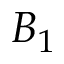<formula> <loc_0><loc_0><loc_500><loc_500>B _ { 1 }</formula> 